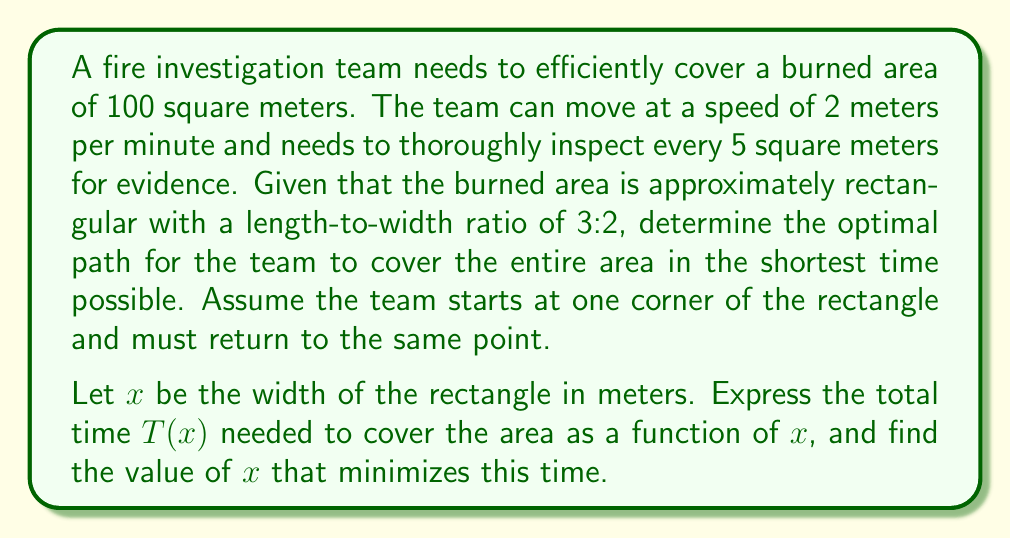Help me with this question. To solve this optimization problem, we'll follow these steps:

1) First, let's establish the dimensions of the rectangle:
   - Area = 100 m²
   - Length:Width ratio = 3:2
   - Let width = $x$ m
   - Then length = $\frac{3x}{2}$ m

2) The area equation: $x \cdot \frac{3x}{2} = 100$
   Simplifying: $\frac{3x^2}{2} = 100$
                $x^2 = \frac{200}{3}$
                $x = \sqrt{\frac{200}{3}} \approx 8.16$ m

3) The optimal path will involve moving back and forth across the width, covering strips of 5 m² each time.

4) Number of strips = $\frac{100}{5} = 20$

5) Distance traveled:
   - Across width: $20x$ (10 times each way)
   - Along length: $19 \cdot \frac{3x}{2}$ (moving between strips)
   - Return to start: $\frac{3x}{2}$

6) Total distance = $20x + 19 \cdot \frac{3x}{2} + \frac{3x}{2} = 20x + 30x = 50x$

7) Time function: $T(x) = \frac{50x}{2} = 25x$ minutes

8) To minimize $T(x)$, we need to minimize $x$ while satisfying the area constraint.
   From step 2, we know $x = \sqrt{\frac{200}{3}}$

9) Therefore, the minimum time is:
   $T_{min} = 25 \sqrt{\frac{200}{3}} \approx 204$ minutes
Answer: The optimal width $x$ is $\sqrt{\frac{200}{3}} \approx 8.16$ meters, and the minimum time required is approximately 204 minutes. 